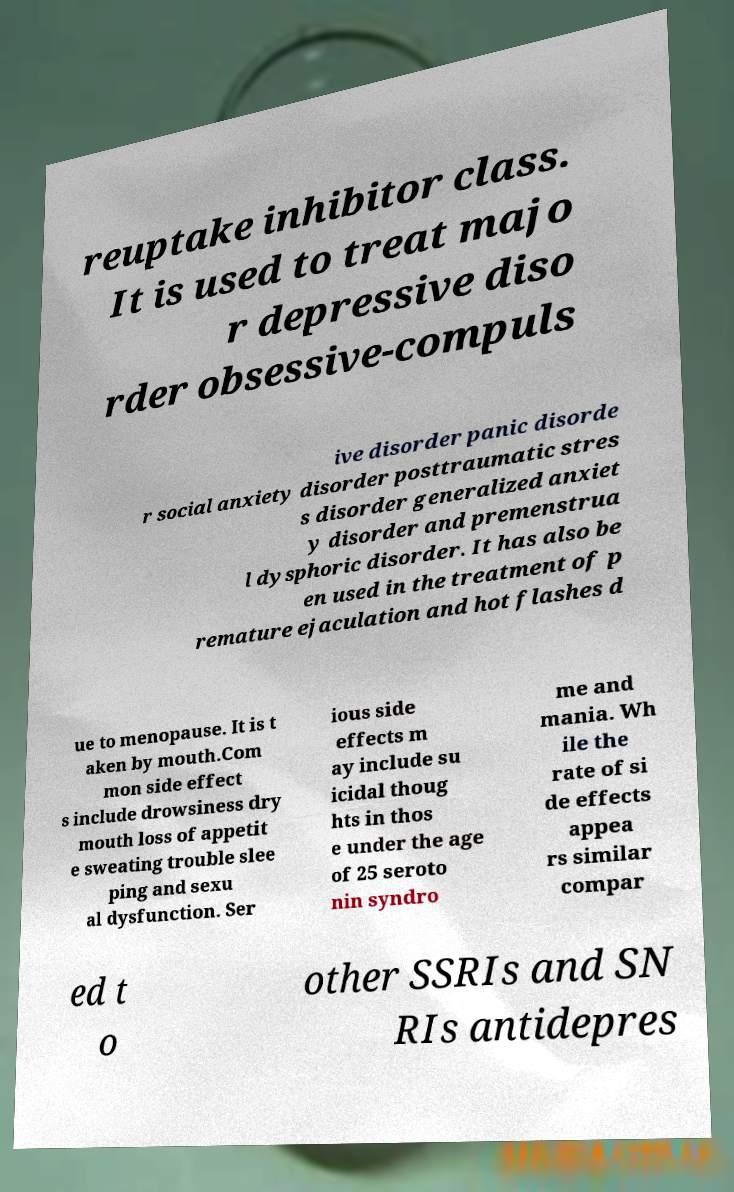Could you extract and type out the text from this image? reuptake inhibitor class. It is used to treat majo r depressive diso rder obsessive-compuls ive disorder panic disorde r social anxiety disorder posttraumatic stres s disorder generalized anxiet y disorder and premenstrua l dysphoric disorder. It has also be en used in the treatment of p remature ejaculation and hot flashes d ue to menopause. It is t aken by mouth.Com mon side effect s include drowsiness dry mouth loss of appetit e sweating trouble slee ping and sexu al dysfunction. Ser ious side effects m ay include su icidal thoug hts in thos e under the age of 25 seroto nin syndro me and mania. Wh ile the rate of si de effects appea rs similar compar ed t o other SSRIs and SN RIs antidepres 